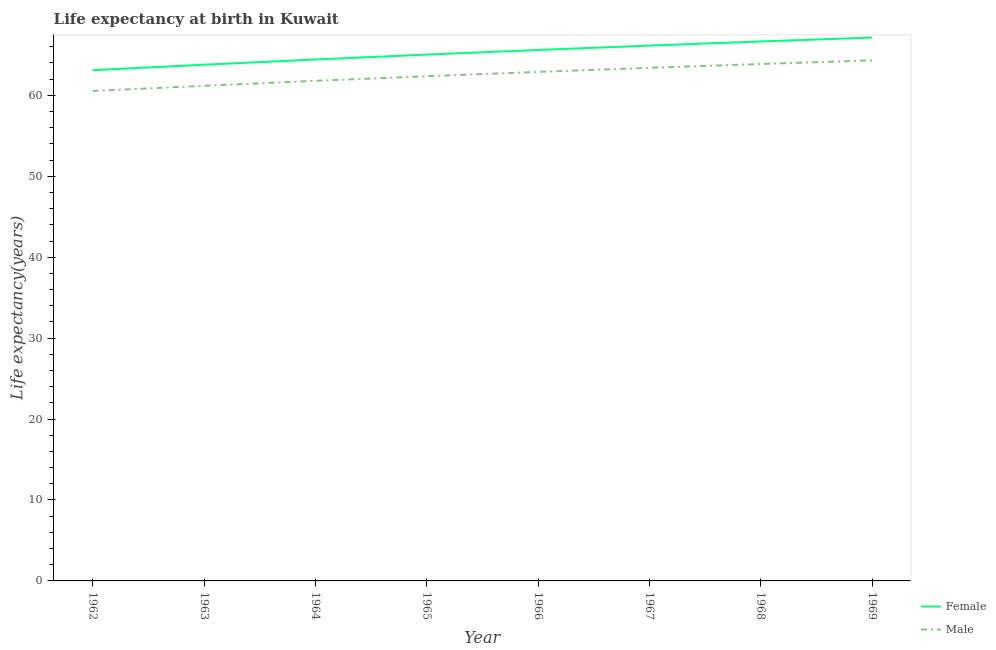How many different coloured lines are there?
Offer a terse response. 2. Does the line corresponding to life expectancy(male) intersect with the line corresponding to life expectancy(female)?
Your answer should be compact. No. Is the number of lines equal to the number of legend labels?
Offer a terse response. Yes. What is the life expectancy(female) in 1963?
Keep it short and to the point. 63.79. Across all years, what is the maximum life expectancy(male)?
Offer a terse response. 64.33. Across all years, what is the minimum life expectancy(female)?
Keep it short and to the point. 63.11. In which year was the life expectancy(female) maximum?
Your answer should be very brief. 1969. In which year was the life expectancy(male) minimum?
Offer a very short reply. 1962. What is the total life expectancy(male) in the graph?
Offer a terse response. 500.39. What is the difference between the life expectancy(female) in 1966 and that in 1967?
Your answer should be compact. -0.54. What is the difference between the life expectancy(male) in 1968 and the life expectancy(female) in 1963?
Offer a terse response. 0.09. What is the average life expectancy(female) per year?
Offer a very short reply. 65.24. In the year 1963, what is the difference between the life expectancy(female) and life expectancy(male)?
Give a very brief answer. 2.6. What is the ratio of the life expectancy(female) in 1962 to that in 1966?
Your response must be concise. 0.96. Is the life expectancy(male) in 1965 less than that in 1967?
Offer a terse response. Yes. Is the difference between the life expectancy(female) in 1963 and 1967 greater than the difference between the life expectancy(male) in 1963 and 1967?
Your answer should be compact. No. What is the difference between the highest and the second highest life expectancy(male)?
Provide a short and direct response. 0.45. What is the difference between the highest and the lowest life expectancy(female)?
Your answer should be compact. 4.04. Does the life expectancy(female) monotonically increase over the years?
Give a very brief answer. Yes. Is the life expectancy(female) strictly greater than the life expectancy(male) over the years?
Offer a terse response. Yes. Is the life expectancy(female) strictly less than the life expectancy(male) over the years?
Provide a succinct answer. No. How many lines are there?
Your answer should be compact. 2. How many years are there in the graph?
Provide a succinct answer. 8. What is the difference between two consecutive major ticks on the Y-axis?
Your answer should be very brief. 10. Does the graph contain grids?
Your answer should be compact. No. Where does the legend appear in the graph?
Your answer should be very brief. Bottom right. What is the title of the graph?
Provide a succinct answer. Life expectancy at birth in Kuwait. What is the label or title of the X-axis?
Your response must be concise. Year. What is the label or title of the Y-axis?
Keep it short and to the point. Life expectancy(years). What is the Life expectancy(years) in Female in 1962?
Your answer should be compact. 63.11. What is the Life expectancy(years) of Male in 1962?
Make the answer very short. 60.54. What is the Life expectancy(years) of Female in 1963?
Your response must be concise. 63.79. What is the Life expectancy(years) in Male in 1963?
Provide a short and direct response. 61.19. What is the Life expectancy(years) of Female in 1964?
Offer a very short reply. 64.43. What is the Life expectancy(years) in Male in 1964?
Your response must be concise. 61.79. What is the Life expectancy(years) of Female in 1965?
Offer a terse response. 65.04. What is the Life expectancy(years) of Male in 1965?
Offer a very short reply. 62.37. What is the Life expectancy(years) in Female in 1966?
Your response must be concise. 65.61. What is the Life expectancy(years) of Male in 1966?
Keep it short and to the point. 62.9. What is the Life expectancy(years) of Female in 1967?
Keep it short and to the point. 66.15. What is the Life expectancy(years) of Male in 1967?
Keep it short and to the point. 63.4. What is the Life expectancy(years) of Female in 1968?
Your response must be concise. 66.66. What is the Life expectancy(years) in Male in 1968?
Make the answer very short. 63.88. What is the Life expectancy(years) in Female in 1969?
Ensure brevity in your answer.  67.14. What is the Life expectancy(years) in Male in 1969?
Your response must be concise. 64.33. Across all years, what is the maximum Life expectancy(years) of Female?
Make the answer very short. 67.14. Across all years, what is the maximum Life expectancy(years) in Male?
Your response must be concise. 64.33. Across all years, what is the minimum Life expectancy(years) of Female?
Offer a very short reply. 63.11. Across all years, what is the minimum Life expectancy(years) of Male?
Provide a short and direct response. 60.54. What is the total Life expectancy(years) of Female in the graph?
Give a very brief answer. 521.94. What is the total Life expectancy(years) in Male in the graph?
Provide a short and direct response. 500.39. What is the difference between the Life expectancy(years) of Female in 1962 and that in 1963?
Keep it short and to the point. -0.68. What is the difference between the Life expectancy(years) of Male in 1962 and that in 1963?
Keep it short and to the point. -0.65. What is the difference between the Life expectancy(years) in Female in 1962 and that in 1964?
Your response must be concise. -1.32. What is the difference between the Life expectancy(years) of Male in 1962 and that in 1964?
Offer a very short reply. -1.25. What is the difference between the Life expectancy(years) in Female in 1962 and that in 1965?
Offer a very short reply. -1.93. What is the difference between the Life expectancy(years) of Male in 1962 and that in 1965?
Keep it short and to the point. -1.82. What is the difference between the Life expectancy(years) in Female in 1962 and that in 1966?
Offer a very short reply. -2.5. What is the difference between the Life expectancy(years) in Male in 1962 and that in 1966?
Offer a terse response. -2.36. What is the difference between the Life expectancy(years) in Female in 1962 and that in 1967?
Offer a very short reply. -3.04. What is the difference between the Life expectancy(years) in Male in 1962 and that in 1967?
Provide a succinct answer. -2.86. What is the difference between the Life expectancy(years) of Female in 1962 and that in 1968?
Keep it short and to the point. -3.55. What is the difference between the Life expectancy(years) of Male in 1962 and that in 1968?
Your response must be concise. -3.34. What is the difference between the Life expectancy(years) of Female in 1962 and that in 1969?
Provide a succinct answer. -4.04. What is the difference between the Life expectancy(years) of Male in 1962 and that in 1969?
Offer a very short reply. -3.79. What is the difference between the Life expectancy(years) of Female in 1963 and that in 1964?
Provide a short and direct response. -0.64. What is the difference between the Life expectancy(years) in Male in 1963 and that in 1964?
Give a very brief answer. -0.61. What is the difference between the Life expectancy(years) of Female in 1963 and that in 1965?
Offer a very short reply. -1.25. What is the difference between the Life expectancy(years) in Male in 1963 and that in 1965?
Your answer should be very brief. -1.18. What is the difference between the Life expectancy(years) in Female in 1963 and that in 1966?
Provide a succinct answer. -1.82. What is the difference between the Life expectancy(years) of Male in 1963 and that in 1966?
Give a very brief answer. -1.71. What is the difference between the Life expectancy(years) of Female in 1963 and that in 1967?
Make the answer very short. -2.36. What is the difference between the Life expectancy(years) in Male in 1963 and that in 1967?
Give a very brief answer. -2.22. What is the difference between the Life expectancy(years) in Female in 1963 and that in 1968?
Your answer should be very brief. -2.87. What is the difference between the Life expectancy(years) of Male in 1963 and that in 1968?
Offer a very short reply. -2.69. What is the difference between the Life expectancy(years) in Female in 1963 and that in 1969?
Offer a very short reply. -3.36. What is the difference between the Life expectancy(years) in Male in 1963 and that in 1969?
Ensure brevity in your answer.  -3.14. What is the difference between the Life expectancy(years) in Female in 1964 and that in 1965?
Your answer should be very brief. -0.61. What is the difference between the Life expectancy(years) of Male in 1964 and that in 1965?
Offer a terse response. -0.57. What is the difference between the Life expectancy(years) of Female in 1964 and that in 1966?
Make the answer very short. -1.18. What is the difference between the Life expectancy(years) in Male in 1964 and that in 1966?
Your response must be concise. -1.11. What is the difference between the Life expectancy(years) of Female in 1964 and that in 1967?
Provide a short and direct response. -1.72. What is the difference between the Life expectancy(years) of Male in 1964 and that in 1967?
Keep it short and to the point. -1.61. What is the difference between the Life expectancy(years) of Female in 1964 and that in 1968?
Your response must be concise. -2.23. What is the difference between the Life expectancy(years) in Male in 1964 and that in 1968?
Ensure brevity in your answer.  -2.08. What is the difference between the Life expectancy(years) in Female in 1964 and that in 1969?
Provide a succinct answer. -2.71. What is the difference between the Life expectancy(years) of Male in 1964 and that in 1969?
Your answer should be compact. -2.53. What is the difference between the Life expectancy(years) in Female in 1965 and that in 1966?
Your answer should be compact. -0.57. What is the difference between the Life expectancy(years) in Male in 1965 and that in 1966?
Keep it short and to the point. -0.54. What is the difference between the Life expectancy(years) in Female in 1965 and that in 1967?
Make the answer very short. -1.11. What is the difference between the Life expectancy(years) of Male in 1965 and that in 1967?
Keep it short and to the point. -1.04. What is the difference between the Life expectancy(years) in Female in 1965 and that in 1968?
Your response must be concise. -1.62. What is the difference between the Life expectancy(years) of Male in 1965 and that in 1968?
Make the answer very short. -1.51. What is the difference between the Life expectancy(years) of Female in 1965 and that in 1969?
Your answer should be very brief. -2.11. What is the difference between the Life expectancy(years) in Male in 1965 and that in 1969?
Offer a terse response. -1.96. What is the difference between the Life expectancy(years) of Female in 1966 and that in 1967?
Make the answer very short. -0.54. What is the difference between the Life expectancy(years) in Male in 1966 and that in 1967?
Ensure brevity in your answer.  -0.5. What is the difference between the Life expectancy(years) in Female in 1966 and that in 1968?
Your answer should be compact. -1.05. What is the difference between the Life expectancy(years) in Male in 1966 and that in 1968?
Make the answer very short. -0.98. What is the difference between the Life expectancy(years) in Female in 1966 and that in 1969?
Your response must be concise. -1.53. What is the difference between the Life expectancy(years) of Male in 1966 and that in 1969?
Ensure brevity in your answer.  -1.43. What is the difference between the Life expectancy(years) in Female in 1967 and that in 1968?
Give a very brief answer. -0.51. What is the difference between the Life expectancy(years) in Male in 1967 and that in 1968?
Your response must be concise. -0.47. What is the difference between the Life expectancy(years) of Female in 1967 and that in 1969?
Provide a succinct answer. -0.99. What is the difference between the Life expectancy(years) of Male in 1967 and that in 1969?
Your response must be concise. -0.92. What is the difference between the Life expectancy(years) of Female in 1968 and that in 1969?
Your answer should be very brief. -0.48. What is the difference between the Life expectancy(years) in Male in 1968 and that in 1969?
Your answer should be compact. -0.45. What is the difference between the Life expectancy(years) of Female in 1962 and the Life expectancy(years) of Male in 1963?
Provide a short and direct response. 1.92. What is the difference between the Life expectancy(years) of Female in 1962 and the Life expectancy(years) of Male in 1964?
Your answer should be very brief. 1.31. What is the difference between the Life expectancy(years) in Female in 1962 and the Life expectancy(years) in Male in 1965?
Your answer should be compact. 0.74. What is the difference between the Life expectancy(years) in Female in 1962 and the Life expectancy(years) in Male in 1966?
Give a very brief answer. 0.21. What is the difference between the Life expectancy(years) of Female in 1962 and the Life expectancy(years) of Male in 1967?
Make the answer very short. -0.29. What is the difference between the Life expectancy(years) in Female in 1962 and the Life expectancy(years) in Male in 1968?
Your response must be concise. -0.77. What is the difference between the Life expectancy(years) in Female in 1962 and the Life expectancy(years) in Male in 1969?
Offer a very short reply. -1.22. What is the difference between the Life expectancy(years) in Female in 1963 and the Life expectancy(years) in Male in 1964?
Keep it short and to the point. 2. What is the difference between the Life expectancy(years) in Female in 1963 and the Life expectancy(years) in Male in 1965?
Keep it short and to the point. 1.42. What is the difference between the Life expectancy(years) in Female in 1963 and the Life expectancy(years) in Male in 1966?
Your answer should be very brief. 0.89. What is the difference between the Life expectancy(years) of Female in 1963 and the Life expectancy(years) of Male in 1967?
Offer a terse response. 0.39. What is the difference between the Life expectancy(years) in Female in 1963 and the Life expectancy(years) in Male in 1968?
Your response must be concise. -0.09. What is the difference between the Life expectancy(years) in Female in 1963 and the Life expectancy(years) in Male in 1969?
Give a very brief answer. -0.54. What is the difference between the Life expectancy(years) in Female in 1964 and the Life expectancy(years) in Male in 1965?
Give a very brief answer. 2.07. What is the difference between the Life expectancy(years) in Female in 1964 and the Life expectancy(years) in Male in 1966?
Give a very brief answer. 1.53. What is the difference between the Life expectancy(years) of Female in 1964 and the Life expectancy(years) of Male in 1968?
Make the answer very short. 0.56. What is the difference between the Life expectancy(years) of Female in 1964 and the Life expectancy(years) of Male in 1969?
Make the answer very short. 0.1. What is the difference between the Life expectancy(years) of Female in 1965 and the Life expectancy(years) of Male in 1966?
Provide a short and direct response. 2.14. What is the difference between the Life expectancy(years) in Female in 1965 and the Life expectancy(years) in Male in 1967?
Make the answer very short. 1.64. What is the difference between the Life expectancy(years) in Female in 1965 and the Life expectancy(years) in Male in 1968?
Give a very brief answer. 1.16. What is the difference between the Life expectancy(years) of Female in 1965 and the Life expectancy(years) of Male in 1969?
Provide a short and direct response. 0.71. What is the difference between the Life expectancy(years) in Female in 1966 and the Life expectancy(years) in Male in 1967?
Your response must be concise. 2.21. What is the difference between the Life expectancy(years) in Female in 1966 and the Life expectancy(years) in Male in 1968?
Offer a terse response. 1.74. What is the difference between the Life expectancy(years) of Female in 1966 and the Life expectancy(years) of Male in 1969?
Your response must be concise. 1.28. What is the difference between the Life expectancy(years) in Female in 1967 and the Life expectancy(years) in Male in 1968?
Your answer should be compact. 2.27. What is the difference between the Life expectancy(years) of Female in 1967 and the Life expectancy(years) of Male in 1969?
Give a very brief answer. 1.82. What is the difference between the Life expectancy(years) of Female in 1968 and the Life expectancy(years) of Male in 1969?
Give a very brief answer. 2.34. What is the average Life expectancy(years) of Female per year?
Your answer should be compact. 65.24. What is the average Life expectancy(years) in Male per year?
Offer a terse response. 62.55. In the year 1962, what is the difference between the Life expectancy(years) in Female and Life expectancy(years) in Male?
Give a very brief answer. 2.57. In the year 1963, what is the difference between the Life expectancy(years) of Female and Life expectancy(years) of Male?
Provide a short and direct response. 2.6. In the year 1964, what is the difference between the Life expectancy(years) of Female and Life expectancy(years) of Male?
Keep it short and to the point. 2.64. In the year 1965, what is the difference between the Life expectancy(years) in Female and Life expectancy(years) in Male?
Your answer should be compact. 2.67. In the year 1966, what is the difference between the Life expectancy(years) in Female and Life expectancy(years) in Male?
Make the answer very short. 2.71. In the year 1967, what is the difference between the Life expectancy(years) of Female and Life expectancy(years) of Male?
Ensure brevity in your answer.  2.75. In the year 1968, what is the difference between the Life expectancy(years) in Female and Life expectancy(years) in Male?
Your answer should be very brief. 2.79. In the year 1969, what is the difference between the Life expectancy(years) of Female and Life expectancy(years) of Male?
Make the answer very short. 2.82. What is the ratio of the Life expectancy(years) of Female in 1962 to that in 1963?
Your answer should be compact. 0.99. What is the ratio of the Life expectancy(years) in Male in 1962 to that in 1963?
Give a very brief answer. 0.99. What is the ratio of the Life expectancy(years) in Female in 1962 to that in 1964?
Offer a terse response. 0.98. What is the ratio of the Life expectancy(years) of Male in 1962 to that in 1964?
Give a very brief answer. 0.98. What is the ratio of the Life expectancy(years) in Female in 1962 to that in 1965?
Give a very brief answer. 0.97. What is the ratio of the Life expectancy(years) of Male in 1962 to that in 1965?
Offer a very short reply. 0.97. What is the ratio of the Life expectancy(years) in Female in 1962 to that in 1966?
Provide a succinct answer. 0.96. What is the ratio of the Life expectancy(years) of Male in 1962 to that in 1966?
Provide a short and direct response. 0.96. What is the ratio of the Life expectancy(years) of Female in 1962 to that in 1967?
Offer a very short reply. 0.95. What is the ratio of the Life expectancy(years) of Male in 1962 to that in 1967?
Provide a succinct answer. 0.95. What is the ratio of the Life expectancy(years) of Female in 1962 to that in 1968?
Make the answer very short. 0.95. What is the ratio of the Life expectancy(years) of Male in 1962 to that in 1968?
Your answer should be very brief. 0.95. What is the ratio of the Life expectancy(years) of Female in 1962 to that in 1969?
Your answer should be compact. 0.94. What is the ratio of the Life expectancy(years) of Male in 1962 to that in 1969?
Provide a short and direct response. 0.94. What is the ratio of the Life expectancy(years) of Female in 1963 to that in 1964?
Your answer should be very brief. 0.99. What is the ratio of the Life expectancy(years) of Male in 1963 to that in 1964?
Provide a succinct answer. 0.99. What is the ratio of the Life expectancy(years) of Female in 1963 to that in 1965?
Provide a short and direct response. 0.98. What is the ratio of the Life expectancy(years) in Male in 1963 to that in 1965?
Your answer should be very brief. 0.98. What is the ratio of the Life expectancy(years) of Female in 1963 to that in 1966?
Make the answer very short. 0.97. What is the ratio of the Life expectancy(years) of Male in 1963 to that in 1966?
Offer a very short reply. 0.97. What is the ratio of the Life expectancy(years) of Male in 1963 to that in 1967?
Provide a succinct answer. 0.96. What is the ratio of the Life expectancy(years) in Female in 1963 to that in 1968?
Your response must be concise. 0.96. What is the ratio of the Life expectancy(years) in Male in 1963 to that in 1968?
Keep it short and to the point. 0.96. What is the ratio of the Life expectancy(years) in Female in 1963 to that in 1969?
Your response must be concise. 0.95. What is the ratio of the Life expectancy(years) of Male in 1963 to that in 1969?
Your response must be concise. 0.95. What is the ratio of the Life expectancy(years) of Female in 1964 to that in 1965?
Your answer should be very brief. 0.99. What is the ratio of the Life expectancy(years) in Male in 1964 to that in 1965?
Make the answer very short. 0.99. What is the ratio of the Life expectancy(years) in Male in 1964 to that in 1966?
Your answer should be compact. 0.98. What is the ratio of the Life expectancy(years) of Female in 1964 to that in 1967?
Provide a short and direct response. 0.97. What is the ratio of the Life expectancy(years) in Male in 1964 to that in 1967?
Your response must be concise. 0.97. What is the ratio of the Life expectancy(years) in Female in 1964 to that in 1968?
Offer a terse response. 0.97. What is the ratio of the Life expectancy(years) of Male in 1964 to that in 1968?
Offer a terse response. 0.97. What is the ratio of the Life expectancy(years) of Female in 1964 to that in 1969?
Offer a terse response. 0.96. What is the ratio of the Life expectancy(years) of Male in 1964 to that in 1969?
Your response must be concise. 0.96. What is the ratio of the Life expectancy(years) of Male in 1965 to that in 1966?
Provide a succinct answer. 0.99. What is the ratio of the Life expectancy(years) of Female in 1965 to that in 1967?
Provide a short and direct response. 0.98. What is the ratio of the Life expectancy(years) in Male in 1965 to that in 1967?
Offer a terse response. 0.98. What is the ratio of the Life expectancy(years) of Female in 1965 to that in 1968?
Your answer should be compact. 0.98. What is the ratio of the Life expectancy(years) in Male in 1965 to that in 1968?
Offer a very short reply. 0.98. What is the ratio of the Life expectancy(years) of Female in 1965 to that in 1969?
Your answer should be compact. 0.97. What is the ratio of the Life expectancy(years) in Male in 1965 to that in 1969?
Your response must be concise. 0.97. What is the ratio of the Life expectancy(years) in Female in 1966 to that in 1968?
Offer a very short reply. 0.98. What is the ratio of the Life expectancy(years) of Male in 1966 to that in 1968?
Keep it short and to the point. 0.98. What is the ratio of the Life expectancy(years) in Female in 1966 to that in 1969?
Your answer should be compact. 0.98. What is the ratio of the Life expectancy(years) of Male in 1966 to that in 1969?
Offer a terse response. 0.98. What is the ratio of the Life expectancy(years) in Female in 1967 to that in 1968?
Provide a short and direct response. 0.99. What is the ratio of the Life expectancy(years) of Male in 1967 to that in 1968?
Provide a succinct answer. 0.99. What is the ratio of the Life expectancy(years) in Female in 1967 to that in 1969?
Ensure brevity in your answer.  0.99. What is the ratio of the Life expectancy(years) in Male in 1967 to that in 1969?
Keep it short and to the point. 0.99. What is the ratio of the Life expectancy(years) in Male in 1968 to that in 1969?
Ensure brevity in your answer.  0.99. What is the difference between the highest and the second highest Life expectancy(years) of Female?
Make the answer very short. 0.48. What is the difference between the highest and the second highest Life expectancy(years) of Male?
Keep it short and to the point. 0.45. What is the difference between the highest and the lowest Life expectancy(years) of Female?
Keep it short and to the point. 4.04. What is the difference between the highest and the lowest Life expectancy(years) in Male?
Make the answer very short. 3.79. 